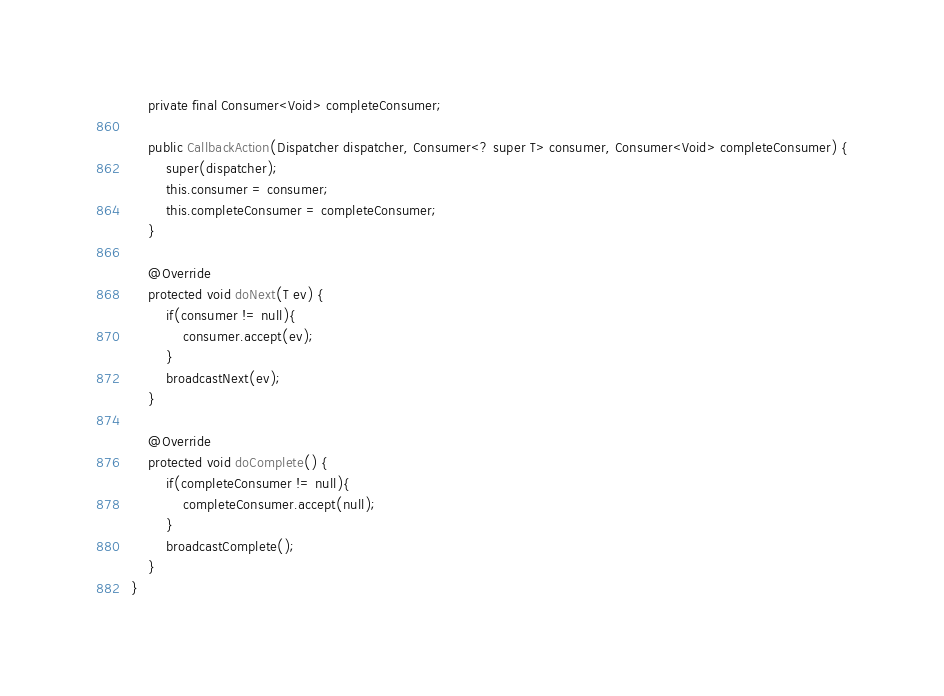Convert code to text. <code><loc_0><loc_0><loc_500><loc_500><_Java_>	private final Consumer<Void> completeConsumer;

	public CallbackAction(Dispatcher dispatcher, Consumer<? super T> consumer, Consumer<Void> completeConsumer) {
		super(dispatcher);
		this.consumer = consumer;
		this.completeConsumer = completeConsumer;
	}

	@Override
	protected void doNext(T ev) {
		if(consumer != null){
			consumer.accept(ev);
		}
		broadcastNext(ev);
	}

	@Override
	protected void doComplete() {
		if(completeConsumer != null){
			completeConsumer.accept(null);
		}
		broadcastComplete();
	}
}
</code> 